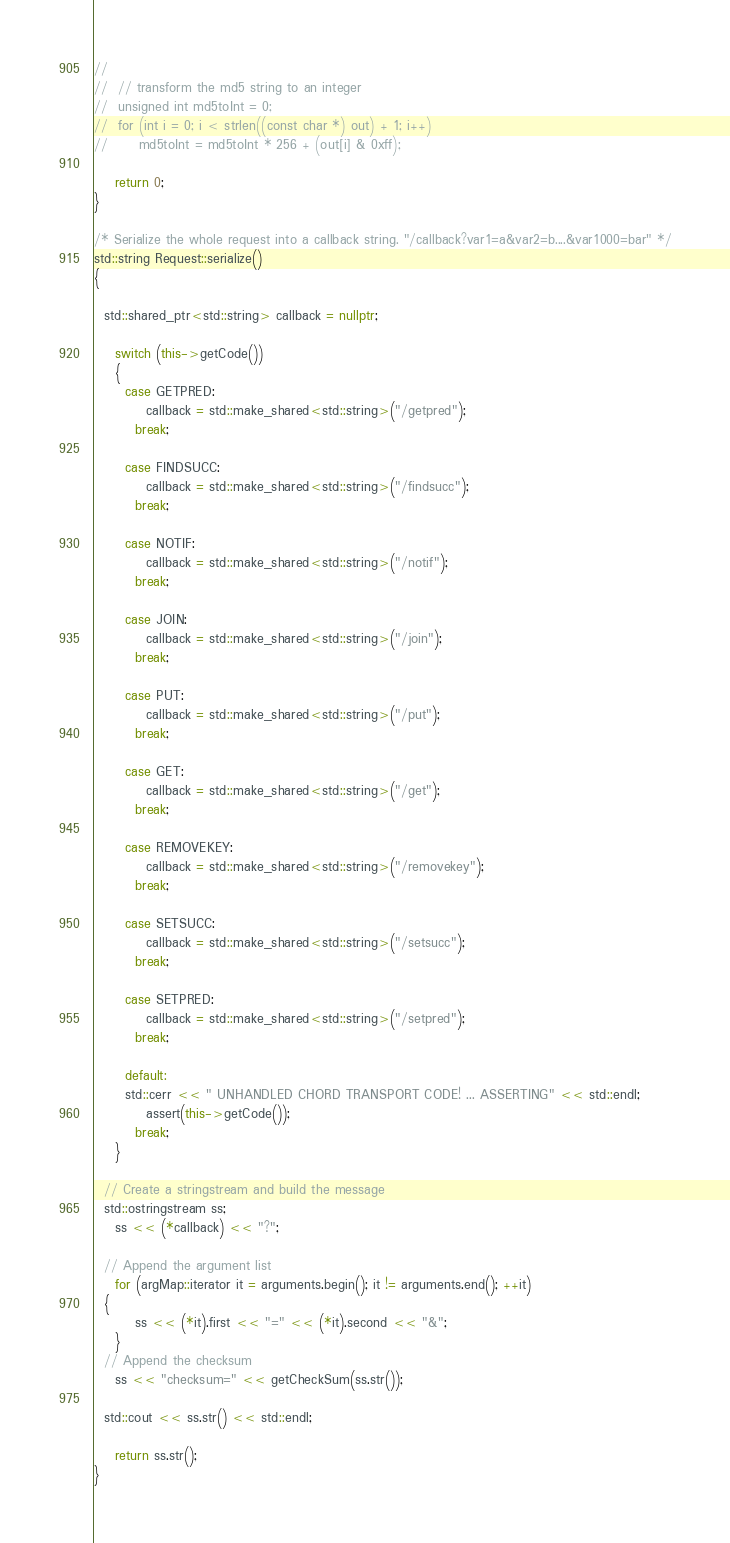<code> <loc_0><loc_0><loc_500><loc_500><_C++_>//
//	// transform the md5 string to an integer
//	unsigned int md5toInt = 0;
//	for (int i = 0; i < strlen((const char *) out) + 1; i++)
//		md5toInt = md5toInt * 256 + (out[i] & 0xff);

	return 0;
}

/* Serialize the whole request into a callback string. "/callback?var1=a&var2=b....&var1000=bar" */
std::string Request::serialize()
{

  std::shared_ptr<std::string> callback = nullptr;

	switch (this->getCode())
	{
	  case GETPRED:
		  callback = std::make_shared<std::string>("/getpred");
		break;

	  case FINDSUCC:
		  callback = std::make_shared<std::string>("/findsucc");
		break;

	  case NOTIF:
		  callback = std::make_shared<std::string>("/notif");
		break;

	  case JOIN:
		  callback = std::make_shared<std::string>("/join");
		break;

	  case PUT:
		  callback = std::make_shared<std::string>("/put");
		break;

	  case GET:
		  callback = std::make_shared<std::string>("/get");
		break;

	  case REMOVEKEY:
		  callback = std::make_shared<std::string>("/removekey");
		break;

	  case SETSUCC:
		  callback = std::make_shared<std::string>("/setsucc");
		break;

	  case SETPRED:
		  callback = std::make_shared<std::string>("/setpred");
		break;

	  default:
      std::cerr << " UNHANDLED CHORD TRANSPORT CODE! ... ASSERTING" << std::endl;
		  assert(this->getCode());
		break;
	}

  // Create a stringstream and build the message
  std::ostringstream ss;
	ss << (*callback) << "?";

  // Append the argument list
	for (argMap::iterator it = arguments.begin(); it != arguments.end(); ++it)
  {
		ss << (*it).first << "=" << (*it).second << "&";
	}
  // Append the checksum
	ss << "checksum=" << getCheckSum(ss.str());

  std::cout << ss.str() << std::endl;

	return ss.str();
}
</code> 